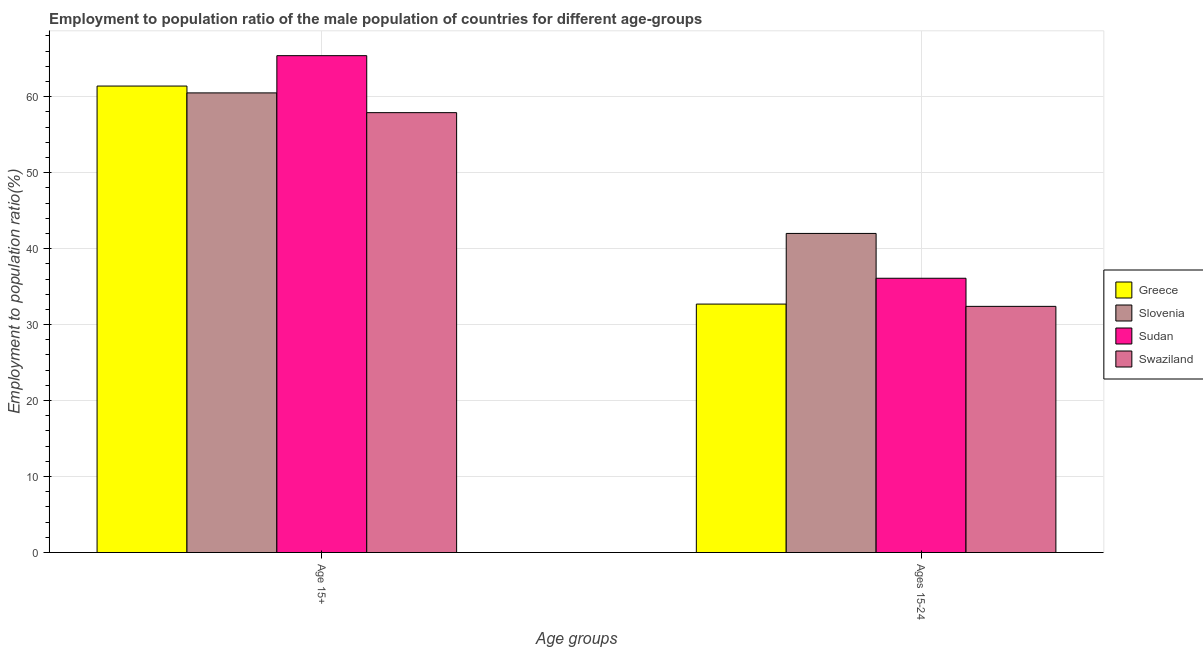Are the number of bars per tick equal to the number of legend labels?
Provide a succinct answer. Yes. How many bars are there on the 1st tick from the left?
Provide a succinct answer. 4. What is the label of the 1st group of bars from the left?
Offer a terse response. Age 15+. Across all countries, what is the maximum employment to population ratio(age 15+)?
Make the answer very short. 65.4. Across all countries, what is the minimum employment to population ratio(age 15+)?
Your answer should be very brief. 57.9. In which country was the employment to population ratio(age 15+) maximum?
Ensure brevity in your answer.  Sudan. In which country was the employment to population ratio(age 15+) minimum?
Your response must be concise. Swaziland. What is the total employment to population ratio(age 15-24) in the graph?
Your answer should be very brief. 143.2. What is the difference between the employment to population ratio(age 15+) in Sudan and that in Greece?
Provide a short and direct response. 4. What is the difference between the employment to population ratio(age 15+) in Slovenia and the employment to population ratio(age 15-24) in Sudan?
Your answer should be very brief. 24.4. What is the average employment to population ratio(age 15+) per country?
Offer a very short reply. 61.3. What is the difference between the employment to population ratio(age 15-24) and employment to population ratio(age 15+) in Slovenia?
Your answer should be compact. -18.5. In how many countries, is the employment to population ratio(age 15+) greater than 62 %?
Your response must be concise. 1. What is the ratio of the employment to population ratio(age 15-24) in Greece to that in Swaziland?
Make the answer very short. 1.01. What does the 4th bar from the right in Ages 15-24 represents?
Your answer should be compact. Greece. How many bars are there?
Your answer should be compact. 8. How many countries are there in the graph?
Your answer should be compact. 4. Are the values on the major ticks of Y-axis written in scientific E-notation?
Provide a succinct answer. No. Does the graph contain any zero values?
Your response must be concise. No. Where does the legend appear in the graph?
Your response must be concise. Center right. What is the title of the graph?
Keep it short and to the point. Employment to population ratio of the male population of countries for different age-groups. Does "Zimbabwe" appear as one of the legend labels in the graph?
Provide a short and direct response. No. What is the label or title of the X-axis?
Make the answer very short. Age groups. What is the Employment to population ratio(%) of Greece in Age 15+?
Ensure brevity in your answer.  61.4. What is the Employment to population ratio(%) of Slovenia in Age 15+?
Your response must be concise. 60.5. What is the Employment to population ratio(%) of Sudan in Age 15+?
Give a very brief answer. 65.4. What is the Employment to population ratio(%) of Swaziland in Age 15+?
Give a very brief answer. 57.9. What is the Employment to population ratio(%) in Greece in Ages 15-24?
Offer a very short reply. 32.7. What is the Employment to population ratio(%) in Sudan in Ages 15-24?
Offer a terse response. 36.1. What is the Employment to population ratio(%) of Swaziland in Ages 15-24?
Ensure brevity in your answer.  32.4. Across all Age groups, what is the maximum Employment to population ratio(%) in Greece?
Make the answer very short. 61.4. Across all Age groups, what is the maximum Employment to population ratio(%) in Slovenia?
Provide a short and direct response. 60.5. Across all Age groups, what is the maximum Employment to population ratio(%) in Sudan?
Offer a very short reply. 65.4. Across all Age groups, what is the maximum Employment to population ratio(%) in Swaziland?
Make the answer very short. 57.9. Across all Age groups, what is the minimum Employment to population ratio(%) of Greece?
Give a very brief answer. 32.7. Across all Age groups, what is the minimum Employment to population ratio(%) of Slovenia?
Make the answer very short. 42. Across all Age groups, what is the minimum Employment to population ratio(%) of Sudan?
Keep it short and to the point. 36.1. Across all Age groups, what is the minimum Employment to population ratio(%) of Swaziland?
Offer a terse response. 32.4. What is the total Employment to population ratio(%) of Greece in the graph?
Your answer should be compact. 94.1. What is the total Employment to population ratio(%) in Slovenia in the graph?
Your answer should be compact. 102.5. What is the total Employment to population ratio(%) in Sudan in the graph?
Make the answer very short. 101.5. What is the total Employment to population ratio(%) in Swaziland in the graph?
Provide a succinct answer. 90.3. What is the difference between the Employment to population ratio(%) of Greece in Age 15+ and that in Ages 15-24?
Provide a succinct answer. 28.7. What is the difference between the Employment to population ratio(%) in Slovenia in Age 15+ and that in Ages 15-24?
Your response must be concise. 18.5. What is the difference between the Employment to population ratio(%) of Sudan in Age 15+ and that in Ages 15-24?
Give a very brief answer. 29.3. What is the difference between the Employment to population ratio(%) in Swaziland in Age 15+ and that in Ages 15-24?
Your response must be concise. 25.5. What is the difference between the Employment to population ratio(%) in Greece in Age 15+ and the Employment to population ratio(%) in Slovenia in Ages 15-24?
Offer a terse response. 19.4. What is the difference between the Employment to population ratio(%) of Greece in Age 15+ and the Employment to population ratio(%) of Sudan in Ages 15-24?
Ensure brevity in your answer.  25.3. What is the difference between the Employment to population ratio(%) of Greece in Age 15+ and the Employment to population ratio(%) of Swaziland in Ages 15-24?
Make the answer very short. 29. What is the difference between the Employment to population ratio(%) of Slovenia in Age 15+ and the Employment to population ratio(%) of Sudan in Ages 15-24?
Offer a terse response. 24.4. What is the difference between the Employment to population ratio(%) in Slovenia in Age 15+ and the Employment to population ratio(%) in Swaziland in Ages 15-24?
Keep it short and to the point. 28.1. What is the average Employment to population ratio(%) in Greece per Age groups?
Give a very brief answer. 47.05. What is the average Employment to population ratio(%) in Slovenia per Age groups?
Ensure brevity in your answer.  51.25. What is the average Employment to population ratio(%) in Sudan per Age groups?
Provide a short and direct response. 50.75. What is the average Employment to population ratio(%) of Swaziland per Age groups?
Ensure brevity in your answer.  45.15. What is the difference between the Employment to population ratio(%) in Greece and Employment to population ratio(%) in Sudan in Age 15+?
Your answer should be very brief. -4. What is the difference between the Employment to population ratio(%) in Slovenia and Employment to population ratio(%) in Sudan in Age 15+?
Make the answer very short. -4.9. What is the difference between the Employment to population ratio(%) in Slovenia and Employment to population ratio(%) in Swaziland in Age 15+?
Provide a short and direct response. 2.6. What is the difference between the Employment to population ratio(%) in Sudan and Employment to population ratio(%) in Swaziland in Age 15+?
Your answer should be very brief. 7.5. What is the difference between the Employment to population ratio(%) of Greece and Employment to population ratio(%) of Sudan in Ages 15-24?
Give a very brief answer. -3.4. What is the difference between the Employment to population ratio(%) in Greece and Employment to population ratio(%) in Swaziland in Ages 15-24?
Make the answer very short. 0.3. What is the difference between the Employment to population ratio(%) in Slovenia and Employment to population ratio(%) in Swaziland in Ages 15-24?
Your response must be concise. 9.6. What is the difference between the Employment to population ratio(%) of Sudan and Employment to population ratio(%) of Swaziland in Ages 15-24?
Ensure brevity in your answer.  3.7. What is the ratio of the Employment to population ratio(%) in Greece in Age 15+ to that in Ages 15-24?
Keep it short and to the point. 1.88. What is the ratio of the Employment to population ratio(%) of Slovenia in Age 15+ to that in Ages 15-24?
Give a very brief answer. 1.44. What is the ratio of the Employment to population ratio(%) in Sudan in Age 15+ to that in Ages 15-24?
Offer a very short reply. 1.81. What is the ratio of the Employment to population ratio(%) of Swaziland in Age 15+ to that in Ages 15-24?
Provide a succinct answer. 1.79. What is the difference between the highest and the second highest Employment to population ratio(%) in Greece?
Offer a very short reply. 28.7. What is the difference between the highest and the second highest Employment to population ratio(%) of Sudan?
Your answer should be compact. 29.3. What is the difference between the highest and the lowest Employment to population ratio(%) in Greece?
Give a very brief answer. 28.7. What is the difference between the highest and the lowest Employment to population ratio(%) of Slovenia?
Provide a succinct answer. 18.5. What is the difference between the highest and the lowest Employment to population ratio(%) in Sudan?
Your answer should be very brief. 29.3. 